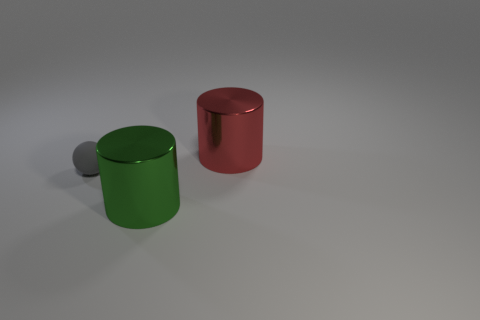What could be the purpose of creating this image? This image might have been created for several purposes: as a render to showcase 3D modeling and lighting techniques, a visual experiment with color and form contrasts, or as an abstract composition to express artistic concepts. The simplicity and clarity of the objects could also imply its use in educational materials to teach about geometry, spatial relationships, or color theory. How might the colors of the cylinders affect a viewer's interpretation? Colors can evoke various emotions and associations. The green cylinder might conjure thoughts of nature, growth, or tranquility, while the red cylinder could convey passion, energy, or danger. The contrast between the two can create a dynamic visual tension, guiding the viewer to compare and contrast the objects based not only on their form but also on the psychological impact of their colors. 